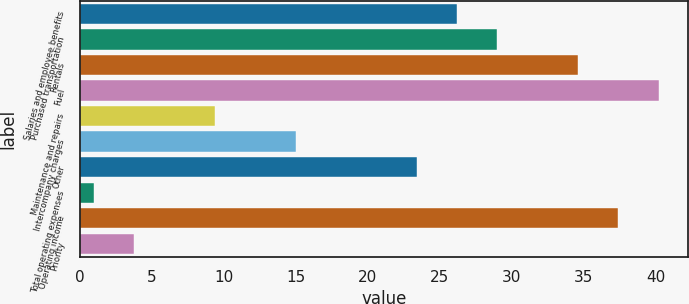Convert chart. <chart><loc_0><loc_0><loc_500><loc_500><bar_chart><fcel>Salaries and employee benefits<fcel>Purchased transportation<fcel>Rentals<fcel>Fuel<fcel>Maintenance and repairs<fcel>Intercompany charges<fcel>Other<fcel>Total operating expenses<fcel>Operating income<fcel>Priority<nl><fcel>26.2<fcel>29<fcel>34.6<fcel>40.2<fcel>9.4<fcel>15<fcel>23.4<fcel>1<fcel>37.4<fcel>3.8<nl></chart> 